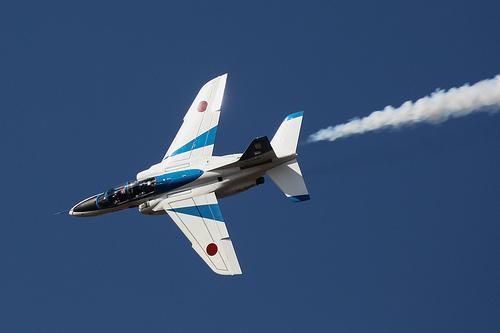How many people are manning the plane?
Give a very brief answer. 2. 